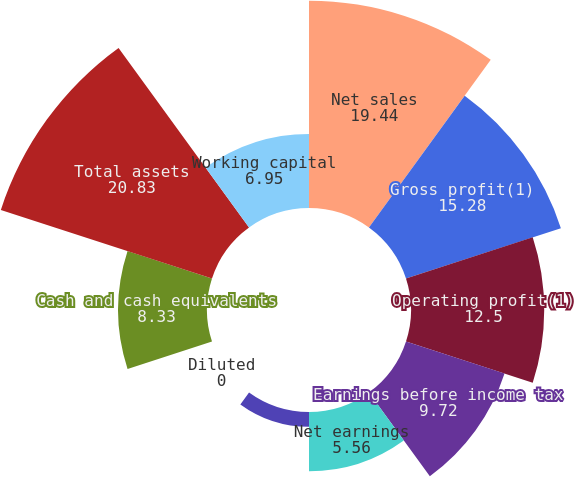Convert chart to OTSL. <chart><loc_0><loc_0><loc_500><loc_500><pie_chart><fcel>Net sales<fcel>Gross profit(1)<fcel>Operating profit(1)<fcel>Earnings before income tax<fcel>Net earnings<fcel>Basic<fcel>Diluted<fcel>Cash and cash equivalents<fcel>Total assets<fcel>Working capital<nl><fcel>19.44%<fcel>15.28%<fcel>12.5%<fcel>9.72%<fcel>5.56%<fcel>1.39%<fcel>0.0%<fcel>8.33%<fcel>20.83%<fcel>6.95%<nl></chart> 